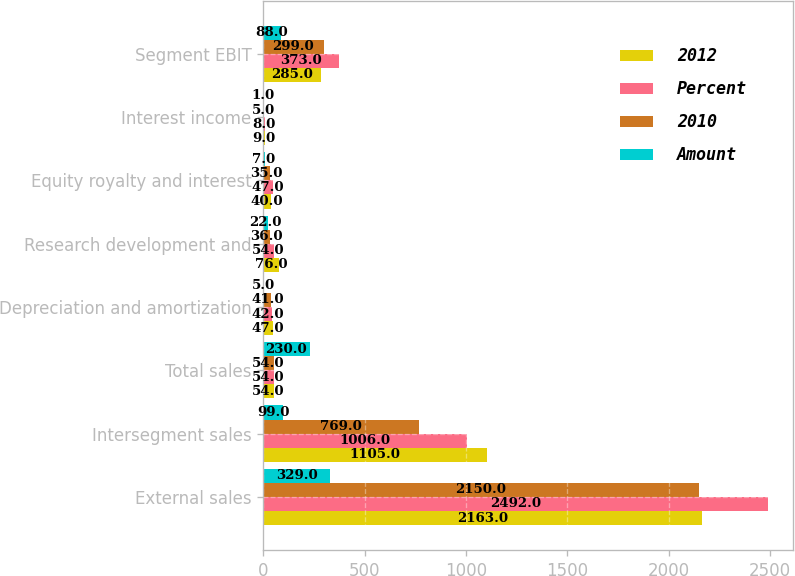<chart> <loc_0><loc_0><loc_500><loc_500><stacked_bar_chart><ecel><fcel>External sales<fcel>Intersegment sales<fcel>Total sales<fcel>Depreciation and amortization<fcel>Research development and<fcel>Equity royalty and interest<fcel>Interest income<fcel>Segment EBIT<nl><fcel>2012<fcel>2163<fcel>1105<fcel>54<fcel>47<fcel>76<fcel>40<fcel>9<fcel>285<nl><fcel>Percent<fcel>2492<fcel>1006<fcel>54<fcel>42<fcel>54<fcel>47<fcel>8<fcel>373<nl><fcel>2010<fcel>2150<fcel>769<fcel>54<fcel>41<fcel>36<fcel>35<fcel>5<fcel>299<nl><fcel>Amount<fcel>329<fcel>99<fcel>230<fcel>5<fcel>22<fcel>7<fcel>1<fcel>88<nl></chart> 